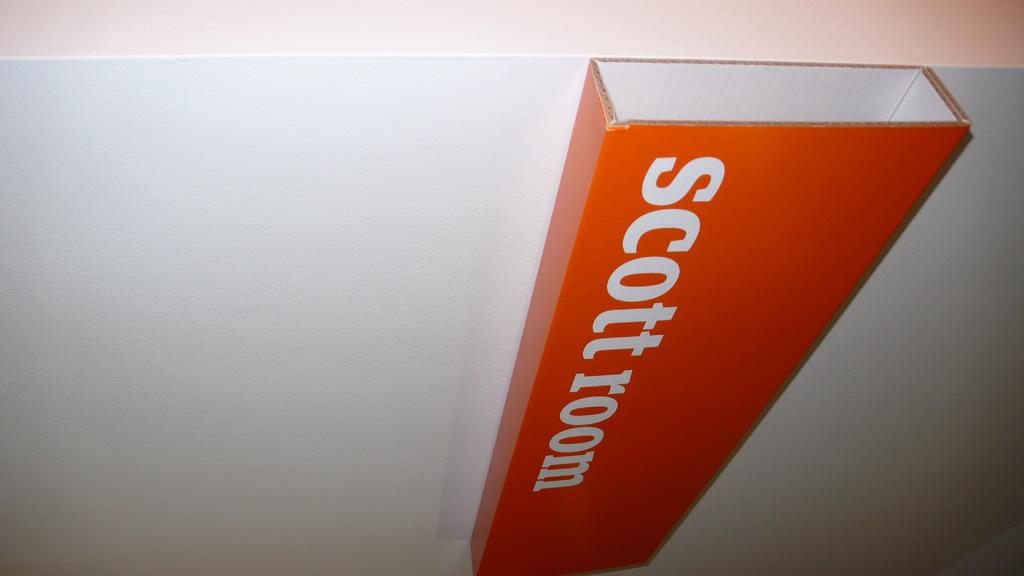<image>
Provide a brief description of the given image. The red and white sign on the wall says scott room. 